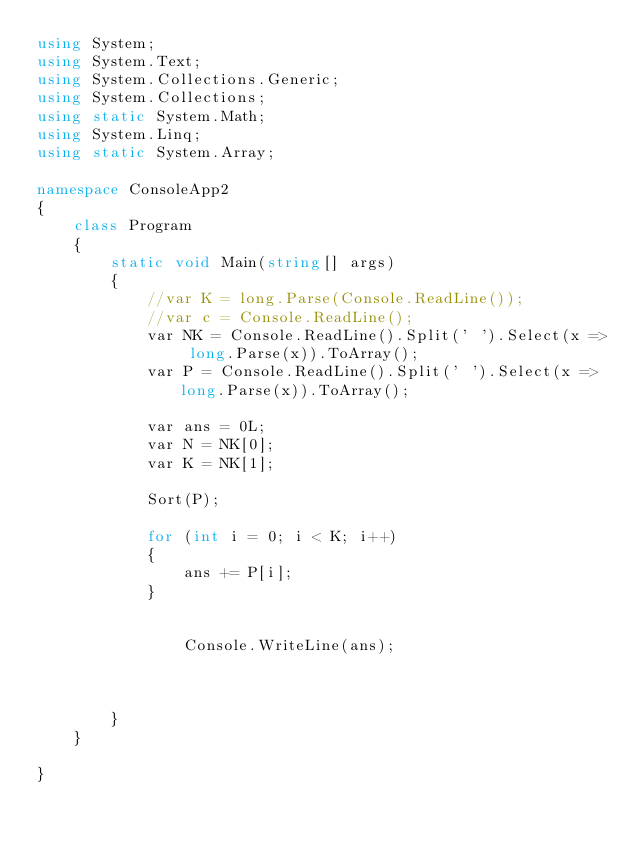<code> <loc_0><loc_0><loc_500><loc_500><_C#_>using System;
using System.Text;
using System.Collections.Generic;
using System.Collections;
using static System.Math;
using System.Linq;
using static System.Array;

namespace ConsoleApp2
{
    class Program
    {
        static void Main(string[] args)
        {
            //var K = long.Parse(Console.ReadLine());
            //var c = Console.ReadLine();
            var NK = Console.ReadLine().Split(' ').Select(x => long.Parse(x)).ToArray();
            var P = Console.ReadLine().Split(' ').Select(x => long.Parse(x)).ToArray();

            var ans = 0L;
            var N = NK[0];
            var K = NK[1];

            Sort(P);

            for (int i = 0; i < K; i++)
            {
                ans += P[i];
            }


                Console.WriteLine(ans);
            
            

        }
    }

}
</code> 